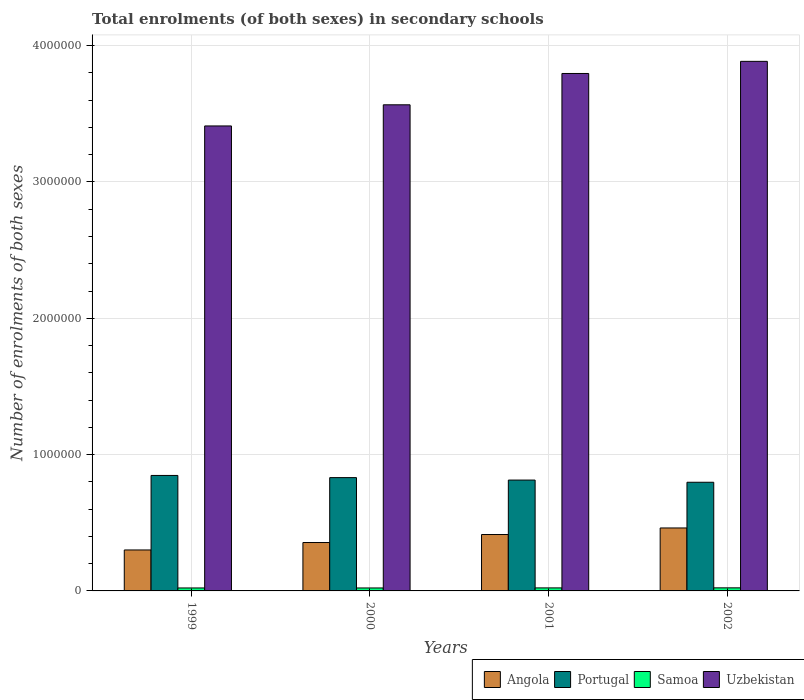How many different coloured bars are there?
Your response must be concise. 4. Are the number of bars per tick equal to the number of legend labels?
Your answer should be very brief. Yes. How many bars are there on the 3rd tick from the left?
Provide a succinct answer. 4. What is the label of the 4th group of bars from the left?
Your answer should be very brief. 2002. In how many cases, is the number of bars for a given year not equal to the number of legend labels?
Your answer should be very brief. 0. What is the number of enrolments in secondary schools in Samoa in 2002?
Provide a succinct answer. 2.26e+04. Across all years, what is the maximum number of enrolments in secondary schools in Uzbekistan?
Your answer should be compact. 3.88e+06. Across all years, what is the minimum number of enrolments in secondary schools in Portugal?
Ensure brevity in your answer.  7.97e+05. In which year was the number of enrolments in secondary schools in Portugal maximum?
Provide a short and direct response. 1999. In which year was the number of enrolments in secondary schools in Samoa minimum?
Your answer should be compact. 2000. What is the total number of enrolments in secondary schools in Samoa in the graph?
Your response must be concise. 8.82e+04. What is the difference between the number of enrolments in secondary schools in Angola in 2000 and that in 2001?
Offer a very short reply. -5.87e+04. What is the difference between the number of enrolments in secondary schools in Portugal in 2000 and the number of enrolments in secondary schools in Uzbekistan in 1999?
Your answer should be very brief. -2.58e+06. What is the average number of enrolments in secondary schools in Samoa per year?
Provide a short and direct response. 2.20e+04. In the year 2002, what is the difference between the number of enrolments in secondary schools in Samoa and number of enrolments in secondary schools in Portugal?
Keep it short and to the point. -7.74e+05. What is the ratio of the number of enrolments in secondary schools in Portugal in 1999 to that in 2002?
Your answer should be compact. 1.06. Is the difference between the number of enrolments in secondary schools in Samoa in 2000 and 2002 greater than the difference between the number of enrolments in secondary schools in Portugal in 2000 and 2002?
Make the answer very short. No. What is the difference between the highest and the second highest number of enrolments in secondary schools in Angola?
Your response must be concise. 4.81e+04. What is the difference between the highest and the lowest number of enrolments in secondary schools in Uzbekistan?
Your answer should be compact. 4.74e+05. In how many years, is the number of enrolments in secondary schools in Angola greater than the average number of enrolments in secondary schools in Angola taken over all years?
Your answer should be compact. 2. Is it the case that in every year, the sum of the number of enrolments in secondary schools in Uzbekistan and number of enrolments in secondary schools in Angola is greater than the sum of number of enrolments in secondary schools in Portugal and number of enrolments in secondary schools in Samoa?
Your answer should be compact. Yes. What does the 3rd bar from the left in 2000 represents?
Offer a terse response. Samoa. What does the 2nd bar from the right in 1999 represents?
Ensure brevity in your answer.  Samoa. Is it the case that in every year, the sum of the number of enrolments in secondary schools in Uzbekistan and number of enrolments in secondary schools in Samoa is greater than the number of enrolments in secondary schools in Angola?
Provide a succinct answer. Yes. What is the difference between two consecutive major ticks on the Y-axis?
Your answer should be very brief. 1.00e+06. Are the values on the major ticks of Y-axis written in scientific E-notation?
Your answer should be compact. No. Does the graph contain any zero values?
Provide a succinct answer. No. Where does the legend appear in the graph?
Give a very brief answer. Bottom right. How many legend labels are there?
Keep it short and to the point. 4. How are the legend labels stacked?
Provide a succinct answer. Horizontal. What is the title of the graph?
Offer a very short reply. Total enrolments (of both sexes) in secondary schools. Does "Kiribati" appear as one of the legend labels in the graph?
Offer a very short reply. No. What is the label or title of the X-axis?
Provide a short and direct response. Years. What is the label or title of the Y-axis?
Your answer should be compact. Number of enrolments of both sexes. What is the Number of enrolments of both sexes in Angola in 1999?
Your response must be concise. 3.00e+05. What is the Number of enrolments of both sexes in Portugal in 1999?
Your response must be concise. 8.47e+05. What is the Number of enrolments of both sexes of Samoa in 1999?
Keep it short and to the point. 2.17e+04. What is the Number of enrolments of both sexes in Uzbekistan in 1999?
Provide a succinct answer. 3.41e+06. What is the Number of enrolments of both sexes of Angola in 2000?
Ensure brevity in your answer.  3.55e+05. What is the Number of enrolments of both sexes in Portugal in 2000?
Your response must be concise. 8.31e+05. What is the Number of enrolments of both sexes in Samoa in 2000?
Provide a short and direct response. 2.17e+04. What is the Number of enrolments of both sexes in Uzbekistan in 2000?
Your answer should be compact. 3.57e+06. What is the Number of enrolments of both sexes in Angola in 2001?
Your response must be concise. 4.14e+05. What is the Number of enrolments of both sexes of Portugal in 2001?
Ensure brevity in your answer.  8.13e+05. What is the Number of enrolments of both sexes of Samoa in 2001?
Ensure brevity in your answer.  2.22e+04. What is the Number of enrolments of both sexes of Uzbekistan in 2001?
Offer a terse response. 3.80e+06. What is the Number of enrolments of both sexes in Angola in 2002?
Make the answer very short. 4.62e+05. What is the Number of enrolments of both sexes of Portugal in 2002?
Keep it short and to the point. 7.97e+05. What is the Number of enrolments of both sexes in Samoa in 2002?
Offer a terse response. 2.26e+04. What is the Number of enrolments of both sexes of Uzbekistan in 2002?
Offer a terse response. 3.88e+06. Across all years, what is the maximum Number of enrolments of both sexes of Angola?
Keep it short and to the point. 4.62e+05. Across all years, what is the maximum Number of enrolments of both sexes in Portugal?
Keep it short and to the point. 8.47e+05. Across all years, what is the maximum Number of enrolments of both sexes in Samoa?
Your answer should be very brief. 2.26e+04. Across all years, what is the maximum Number of enrolments of both sexes of Uzbekistan?
Your answer should be compact. 3.88e+06. Across all years, what is the minimum Number of enrolments of both sexes of Angola?
Provide a short and direct response. 3.00e+05. Across all years, what is the minimum Number of enrolments of both sexes in Portugal?
Your answer should be very brief. 7.97e+05. Across all years, what is the minimum Number of enrolments of both sexes of Samoa?
Your answer should be compact. 2.17e+04. Across all years, what is the minimum Number of enrolments of both sexes of Uzbekistan?
Your answer should be very brief. 3.41e+06. What is the total Number of enrolments of both sexes of Angola in the graph?
Provide a succinct answer. 1.53e+06. What is the total Number of enrolments of both sexes of Portugal in the graph?
Offer a very short reply. 3.29e+06. What is the total Number of enrolments of both sexes of Samoa in the graph?
Provide a short and direct response. 8.82e+04. What is the total Number of enrolments of both sexes of Uzbekistan in the graph?
Keep it short and to the point. 1.47e+07. What is the difference between the Number of enrolments of both sexes in Angola in 1999 and that in 2000?
Offer a terse response. -5.45e+04. What is the difference between the Number of enrolments of both sexes of Portugal in 1999 and that in 2000?
Provide a succinct answer. 1.59e+04. What is the difference between the Number of enrolments of both sexes of Samoa in 1999 and that in 2000?
Keep it short and to the point. 67. What is the difference between the Number of enrolments of both sexes in Uzbekistan in 1999 and that in 2000?
Keep it short and to the point. -1.55e+05. What is the difference between the Number of enrolments of both sexes of Angola in 1999 and that in 2001?
Your answer should be very brief. -1.13e+05. What is the difference between the Number of enrolments of both sexes of Portugal in 1999 and that in 2001?
Your answer should be very brief. 3.40e+04. What is the difference between the Number of enrolments of both sexes in Samoa in 1999 and that in 2001?
Offer a terse response. -437. What is the difference between the Number of enrolments of both sexes in Uzbekistan in 1999 and that in 2001?
Provide a succinct answer. -3.85e+05. What is the difference between the Number of enrolments of both sexes in Angola in 1999 and that in 2002?
Give a very brief answer. -1.61e+05. What is the difference between the Number of enrolments of both sexes of Portugal in 1999 and that in 2002?
Your answer should be compact. 5.01e+04. What is the difference between the Number of enrolments of both sexes in Samoa in 1999 and that in 2002?
Make the answer very short. -827. What is the difference between the Number of enrolments of both sexes in Uzbekistan in 1999 and that in 2002?
Offer a terse response. -4.74e+05. What is the difference between the Number of enrolments of both sexes of Angola in 2000 and that in 2001?
Provide a short and direct response. -5.87e+04. What is the difference between the Number of enrolments of both sexes of Portugal in 2000 and that in 2001?
Make the answer very short. 1.80e+04. What is the difference between the Number of enrolments of both sexes of Samoa in 2000 and that in 2001?
Offer a very short reply. -504. What is the difference between the Number of enrolments of both sexes in Uzbekistan in 2000 and that in 2001?
Ensure brevity in your answer.  -2.30e+05. What is the difference between the Number of enrolments of both sexes of Angola in 2000 and that in 2002?
Keep it short and to the point. -1.07e+05. What is the difference between the Number of enrolments of both sexes of Portugal in 2000 and that in 2002?
Provide a short and direct response. 3.41e+04. What is the difference between the Number of enrolments of both sexes in Samoa in 2000 and that in 2002?
Provide a short and direct response. -894. What is the difference between the Number of enrolments of both sexes of Uzbekistan in 2000 and that in 2002?
Ensure brevity in your answer.  -3.19e+05. What is the difference between the Number of enrolments of both sexes in Angola in 2001 and that in 2002?
Provide a succinct answer. -4.81e+04. What is the difference between the Number of enrolments of both sexes in Portugal in 2001 and that in 2002?
Your answer should be compact. 1.61e+04. What is the difference between the Number of enrolments of both sexes in Samoa in 2001 and that in 2002?
Keep it short and to the point. -390. What is the difference between the Number of enrolments of both sexes of Uzbekistan in 2001 and that in 2002?
Offer a terse response. -8.89e+04. What is the difference between the Number of enrolments of both sexes of Angola in 1999 and the Number of enrolments of both sexes of Portugal in 2000?
Offer a terse response. -5.31e+05. What is the difference between the Number of enrolments of both sexes of Angola in 1999 and the Number of enrolments of both sexes of Samoa in 2000?
Offer a terse response. 2.79e+05. What is the difference between the Number of enrolments of both sexes in Angola in 1999 and the Number of enrolments of both sexes in Uzbekistan in 2000?
Ensure brevity in your answer.  -3.27e+06. What is the difference between the Number of enrolments of both sexes of Portugal in 1999 and the Number of enrolments of both sexes of Samoa in 2000?
Your response must be concise. 8.25e+05. What is the difference between the Number of enrolments of both sexes in Portugal in 1999 and the Number of enrolments of both sexes in Uzbekistan in 2000?
Your answer should be very brief. -2.72e+06. What is the difference between the Number of enrolments of both sexes of Samoa in 1999 and the Number of enrolments of both sexes of Uzbekistan in 2000?
Give a very brief answer. -3.54e+06. What is the difference between the Number of enrolments of both sexes of Angola in 1999 and the Number of enrolments of both sexes of Portugal in 2001?
Make the answer very short. -5.13e+05. What is the difference between the Number of enrolments of both sexes of Angola in 1999 and the Number of enrolments of both sexes of Samoa in 2001?
Your answer should be compact. 2.78e+05. What is the difference between the Number of enrolments of both sexes of Angola in 1999 and the Number of enrolments of both sexes of Uzbekistan in 2001?
Provide a short and direct response. -3.50e+06. What is the difference between the Number of enrolments of both sexes of Portugal in 1999 and the Number of enrolments of both sexes of Samoa in 2001?
Your response must be concise. 8.25e+05. What is the difference between the Number of enrolments of both sexes in Portugal in 1999 and the Number of enrolments of both sexes in Uzbekistan in 2001?
Make the answer very short. -2.95e+06. What is the difference between the Number of enrolments of both sexes in Samoa in 1999 and the Number of enrolments of both sexes in Uzbekistan in 2001?
Offer a very short reply. -3.77e+06. What is the difference between the Number of enrolments of both sexes in Angola in 1999 and the Number of enrolments of both sexes in Portugal in 2002?
Your answer should be compact. -4.97e+05. What is the difference between the Number of enrolments of both sexes of Angola in 1999 and the Number of enrolments of both sexes of Samoa in 2002?
Ensure brevity in your answer.  2.78e+05. What is the difference between the Number of enrolments of both sexes in Angola in 1999 and the Number of enrolments of both sexes in Uzbekistan in 2002?
Your answer should be very brief. -3.58e+06. What is the difference between the Number of enrolments of both sexes of Portugal in 1999 and the Number of enrolments of both sexes of Samoa in 2002?
Keep it short and to the point. 8.25e+05. What is the difference between the Number of enrolments of both sexes in Portugal in 1999 and the Number of enrolments of both sexes in Uzbekistan in 2002?
Your response must be concise. -3.04e+06. What is the difference between the Number of enrolments of both sexes of Samoa in 1999 and the Number of enrolments of both sexes of Uzbekistan in 2002?
Provide a short and direct response. -3.86e+06. What is the difference between the Number of enrolments of both sexes of Angola in 2000 and the Number of enrolments of both sexes of Portugal in 2001?
Offer a terse response. -4.58e+05. What is the difference between the Number of enrolments of both sexes in Angola in 2000 and the Number of enrolments of both sexes in Samoa in 2001?
Your answer should be very brief. 3.33e+05. What is the difference between the Number of enrolments of both sexes of Angola in 2000 and the Number of enrolments of both sexes of Uzbekistan in 2001?
Provide a short and direct response. -3.44e+06. What is the difference between the Number of enrolments of both sexes of Portugal in 2000 and the Number of enrolments of both sexes of Samoa in 2001?
Give a very brief answer. 8.09e+05. What is the difference between the Number of enrolments of both sexes of Portugal in 2000 and the Number of enrolments of both sexes of Uzbekistan in 2001?
Keep it short and to the point. -2.96e+06. What is the difference between the Number of enrolments of both sexes in Samoa in 2000 and the Number of enrolments of both sexes in Uzbekistan in 2001?
Ensure brevity in your answer.  -3.77e+06. What is the difference between the Number of enrolments of both sexes of Angola in 2000 and the Number of enrolments of both sexes of Portugal in 2002?
Make the answer very short. -4.42e+05. What is the difference between the Number of enrolments of both sexes of Angola in 2000 and the Number of enrolments of both sexes of Samoa in 2002?
Offer a very short reply. 3.32e+05. What is the difference between the Number of enrolments of both sexes in Angola in 2000 and the Number of enrolments of both sexes in Uzbekistan in 2002?
Provide a short and direct response. -3.53e+06. What is the difference between the Number of enrolments of both sexes in Portugal in 2000 and the Number of enrolments of both sexes in Samoa in 2002?
Your answer should be compact. 8.09e+05. What is the difference between the Number of enrolments of both sexes of Portugal in 2000 and the Number of enrolments of both sexes of Uzbekistan in 2002?
Give a very brief answer. -3.05e+06. What is the difference between the Number of enrolments of both sexes of Samoa in 2000 and the Number of enrolments of both sexes of Uzbekistan in 2002?
Make the answer very short. -3.86e+06. What is the difference between the Number of enrolments of both sexes in Angola in 2001 and the Number of enrolments of both sexes in Portugal in 2002?
Ensure brevity in your answer.  -3.83e+05. What is the difference between the Number of enrolments of both sexes of Angola in 2001 and the Number of enrolments of both sexes of Samoa in 2002?
Offer a very short reply. 3.91e+05. What is the difference between the Number of enrolments of both sexes of Angola in 2001 and the Number of enrolments of both sexes of Uzbekistan in 2002?
Ensure brevity in your answer.  -3.47e+06. What is the difference between the Number of enrolments of both sexes of Portugal in 2001 and the Number of enrolments of both sexes of Samoa in 2002?
Your answer should be very brief. 7.91e+05. What is the difference between the Number of enrolments of both sexes in Portugal in 2001 and the Number of enrolments of both sexes in Uzbekistan in 2002?
Offer a very short reply. -3.07e+06. What is the difference between the Number of enrolments of both sexes of Samoa in 2001 and the Number of enrolments of both sexes of Uzbekistan in 2002?
Make the answer very short. -3.86e+06. What is the average Number of enrolments of both sexes in Angola per year?
Give a very brief answer. 3.83e+05. What is the average Number of enrolments of both sexes of Portugal per year?
Your response must be concise. 8.22e+05. What is the average Number of enrolments of both sexes in Samoa per year?
Make the answer very short. 2.20e+04. What is the average Number of enrolments of both sexes of Uzbekistan per year?
Your answer should be very brief. 3.66e+06. In the year 1999, what is the difference between the Number of enrolments of both sexes of Angola and Number of enrolments of both sexes of Portugal?
Your response must be concise. -5.47e+05. In the year 1999, what is the difference between the Number of enrolments of both sexes in Angola and Number of enrolments of both sexes in Samoa?
Offer a terse response. 2.79e+05. In the year 1999, what is the difference between the Number of enrolments of both sexes in Angola and Number of enrolments of both sexes in Uzbekistan?
Your answer should be compact. -3.11e+06. In the year 1999, what is the difference between the Number of enrolments of both sexes of Portugal and Number of enrolments of both sexes of Samoa?
Ensure brevity in your answer.  8.25e+05. In the year 1999, what is the difference between the Number of enrolments of both sexes in Portugal and Number of enrolments of both sexes in Uzbekistan?
Your response must be concise. -2.56e+06. In the year 1999, what is the difference between the Number of enrolments of both sexes in Samoa and Number of enrolments of both sexes in Uzbekistan?
Provide a succinct answer. -3.39e+06. In the year 2000, what is the difference between the Number of enrolments of both sexes in Angola and Number of enrolments of both sexes in Portugal?
Ensure brevity in your answer.  -4.76e+05. In the year 2000, what is the difference between the Number of enrolments of both sexes in Angola and Number of enrolments of both sexes in Samoa?
Your answer should be very brief. 3.33e+05. In the year 2000, what is the difference between the Number of enrolments of both sexes of Angola and Number of enrolments of both sexes of Uzbekistan?
Your answer should be compact. -3.21e+06. In the year 2000, what is the difference between the Number of enrolments of both sexes of Portugal and Number of enrolments of both sexes of Samoa?
Provide a short and direct response. 8.10e+05. In the year 2000, what is the difference between the Number of enrolments of both sexes of Portugal and Number of enrolments of both sexes of Uzbekistan?
Keep it short and to the point. -2.73e+06. In the year 2000, what is the difference between the Number of enrolments of both sexes in Samoa and Number of enrolments of both sexes in Uzbekistan?
Your response must be concise. -3.54e+06. In the year 2001, what is the difference between the Number of enrolments of both sexes in Angola and Number of enrolments of both sexes in Portugal?
Make the answer very short. -3.99e+05. In the year 2001, what is the difference between the Number of enrolments of both sexes in Angola and Number of enrolments of both sexes in Samoa?
Give a very brief answer. 3.92e+05. In the year 2001, what is the difference between the Number of enrolments of both sexes of Angola and Number of enrolments of both sexes of Uzbekistan?
Offer a terse response. -3.38e+06. In the year 2001, what is the difference between the Number of enrolments of both sexes in Portugal and Number of enrolments of both sexes in Samoa?
Provide a succinct answer. 7.91e+05. In the year 2001, what is the difference between the Number of enrolments of both sexes of Portugal and Number of enrolments of both sexes of Uzbekistan?
Ensure brevity in your answer.  -2.98e+06. In the year 2001, what is the difference between the Number of enrolments of both sexes in Samoa and Number of enrolments of both sexes in Uzbekistan?
Offer a terse response. -3.77e+06. In the year 2002, what is the difference between the Number of enrolments of both sexes of Angola and Number of enrolments of both sexes of Portugal?
Your response must be concise. -3.35e+05. In the year 2002, what is the difference between the Number of enrolments of both sexes in Angola and Number of enrolments of both sexes in Samoa?
Provide a succinct answer. 4.39e+05. In the year 2002, what is the difference between the Number of enrolments of both sexes in Angola and Number of enrolments of both sexes in Uzbekistan?
Offer a very short reply. -3.42e+06. In the year 2002, what is the difference between the Number of enrolments of both sexes of Portugal and Number of enrolments of both sexes of Samoa?
Keep it short and to the point. 7.74e+05. In the year 2002, what is the difference between the Number of enrolments of both sexes in Portugal and Number of enrolments of both sexes in Uzbekistan?
Give a very brief answer. -3.09e+06. In the year 2002, what is the difference between the Number of enrolments of both sexes of Samoa and Number of enrolments of both sexes of Uzbekistan?
Provide a short and direct response. -3.86e+06. What is the ratio of the Number of enrolments of both sexes of Angola in 1999 to that in 2000?
Offer a very short reply. 0.85. What is the ratio of the Number of enrolments of both sexes in Portugal in 1999 to that in 2000?
Your answer should be compact. 1.02. What is the ratio of the Number of enrolments of both sexes of Uzbekistan in 1999 to that in 2000?
Your response must be concise. 0.96. What is the ratio of the Number of enrolments of both sexes of Angola in 1999 to that in 2001?
Provide a short and direct response. 0.73. What is the ratio of the Number of enrolments of both sexes in Portugal in 1999 to that in 2001?
Offer a very short reply. 1.04. What is the ratio of the Number of enrolments of both sexes in Samoa in 1999 to that in 2001?
Make the answer very short. 0.98. What is the ratio of the Number of enrolments of both sexes in Uzbekistan in 1999 to that in 2001?
Provide a short and direct response. 0.9. What is the ratio of the Number of enrolments of both sexes in Angola in 1999 to that in 2002?
Your answer should be compact. 0.65. What is the ratio of the Number of enrolments of both sexes of Portugal in 1999 to that in 2002?
Offer a very short reply. 1.06. What is the ratio of the Number of enrolments of both sexes of Samoa in 1999 to that in 2002?
Offer a terse response. 0.96. What is the ratio of the Number of enrolments of both sexes in Uzbekistan in 1999 to that in 2002?
Your response must be concise. 0.88. What is the ratio of the Number of enrolments of both sexes of Angola in 2000 to that in 2001?
Your answer should be compact. 0.86. What is the ratio of the Number of enrolments of both sexes in Portugal in 2000 to that in 2001?
Your answer should be very brief. 1.02. What is the ratio of the Number of enrolments of both sexes in Samoa in 2000 to that in 2001?
Offer a terse response. 0.98. What is the ratio of the Number of enrolments of both sexes of Uzbekistan in 2000 to that in 2001?
Your answer should be compact. 0.94. What is the ratio of the Number of enrolments of both sexes in Angola in 2000 to that in 2002?
Ensure brevity in your answer.  0.77. What is the ratio of the Number of enrolments of both sexes of Portugal in 2000 to that in 2002?
Provide a short and direct response. 1.04. What is the ratio of the Number of enrolments of both sexes of Samoa in 2000 to that in 2002?
Offer a terse response. 0.96. What is the ratio of the Number of enrolments of both sexes in Uzbekistan in 2000 to that in 2002?
Keep it short and to the point. 0.92. What is the ratio of the Number of enrolments of both sexes of Angola in 2001 to that in 2002?
Give a very brief answer. 0.9. What is the ratio of the Number of enrolments of both sexes in Portugal in 2001 to that in 2002?
Provide a succinct answer. 1.02. What is the ratio of the Number of enrolments of both sexes in Samoa in 2001 to that in 2002?
Offer a very short reply. 0.98. What is the ratio of the Number of enrolments of both sexes in Uzbekistan in 2001 to that in 2002?
Ensure brevity in your answer.  0.98. What is the difference between the highest and the second highest Number of enrolments of both sexes in Angola?
Your answer should be compact. 4.81e+04. What is the difference between the highest and the second highest Number of enrolments of both sexes in Portugal?
Your answer should be very brief. 1.59e+04. What is the difference between the highest and the second highest Number of enrolments of both sexes of Samoa?
Your answer should be compact. 390. What is the difference between the highest and the second highest Number of enrolments of both sexes in Uzbekistan?
Your answer should be very brief. 8.89e+04. What is the difference between the highest and the lowest Number of enrolments of both sexes of Angola?
Offer a very short reply. 1.61e+05. What is the difference between the highest and the lowest Number of enrolments of both sexes of Portugal?
Your response must be concise. 5.01e+04. What is the difference between the highest and the lowest Number of enrolments of both sexes in Samoa?
Provide a short and direct response. 894. What is the difference between the highest and the lowest Number of enrolments of both sexes of Uzbekistan?
Your answer should be very brief. 4.74e+05. 